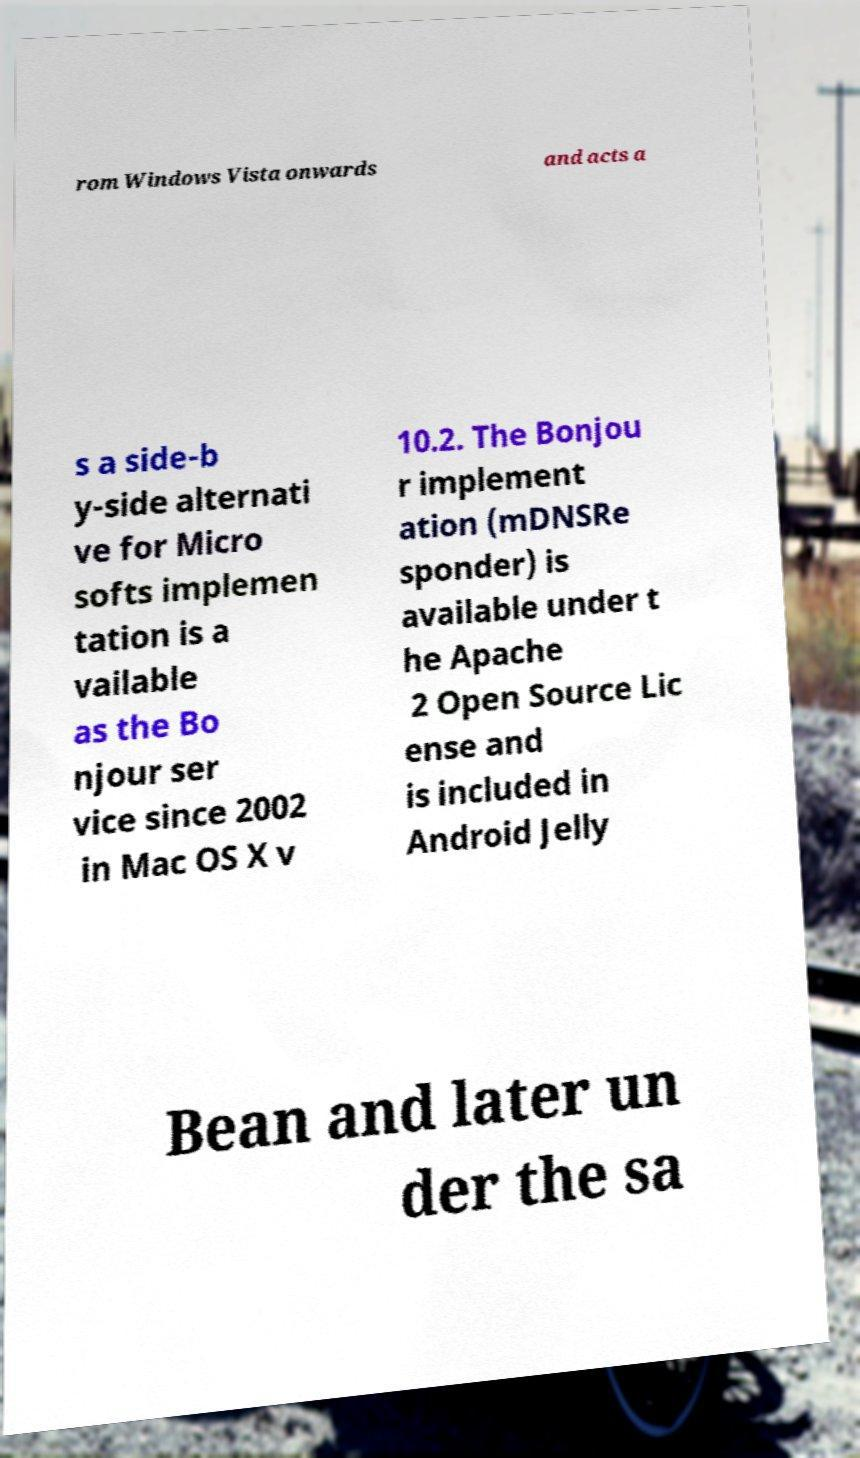Can you accurately transcribe the text from the provided image for me? rom Windows Vista onwards and acts a s a side-b y-side alternati ve for Micro softs implemen tation is a vailable as the Bo njour ser vice since 2002 in Mac OS X v 10.2. The Bonjou r implement ation (mDNSRe sponder) is available under t he Apache 2 Open Source Lic ense and is included in Android Jelly Bean and later un der the sa 